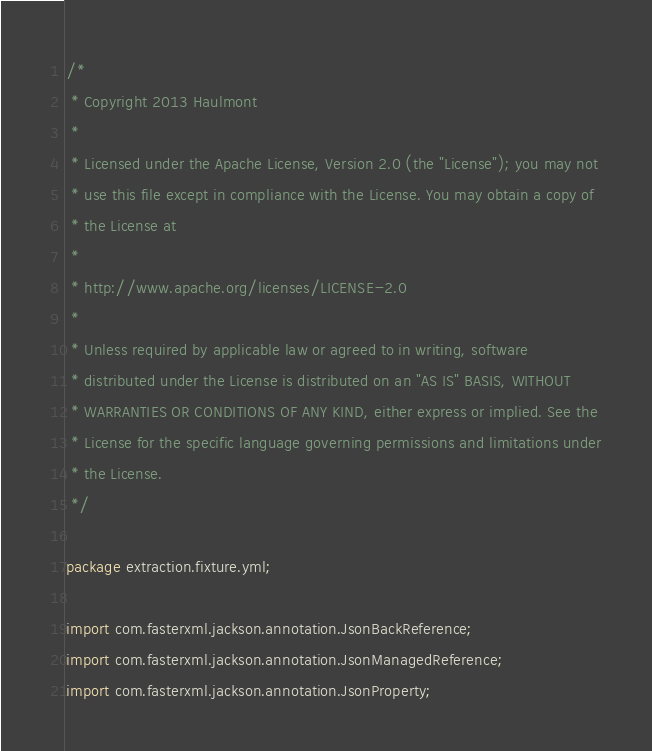Convert code to text. <code><loc_0><loc_0><loc_500><loc_500><_Java_>/*
 * Copyright 2013 Haulmont
 *
 * Licensed under the Apache License, Version 2.0 (the "License"); you may not
 * use this file except in compliance with the License. You may obtain a copy of
 * the License at
 *
 * http://www.apache.org/licenses/LICENSE-2.0
 *
 * Unless required by applicable law or agreed to in writing, software
 * distributed under the License is distributed on an "AS IS" BASIS, WITHOUT
 * WARRANTIES OR CONDITIONS OF ANY KIND, either express or implied. See the
 * License for the specific language governing permissions and limitations under
 * the License.
 */

package extraction.fixture.yml;

import com.fasterxml.jackson.annotation.JsonBackReference;
import com.fasterxml.jackson.annotation.JsonManagedReference;
import com.fasterxml.jackson.annotation.JsonProperty;</code> 